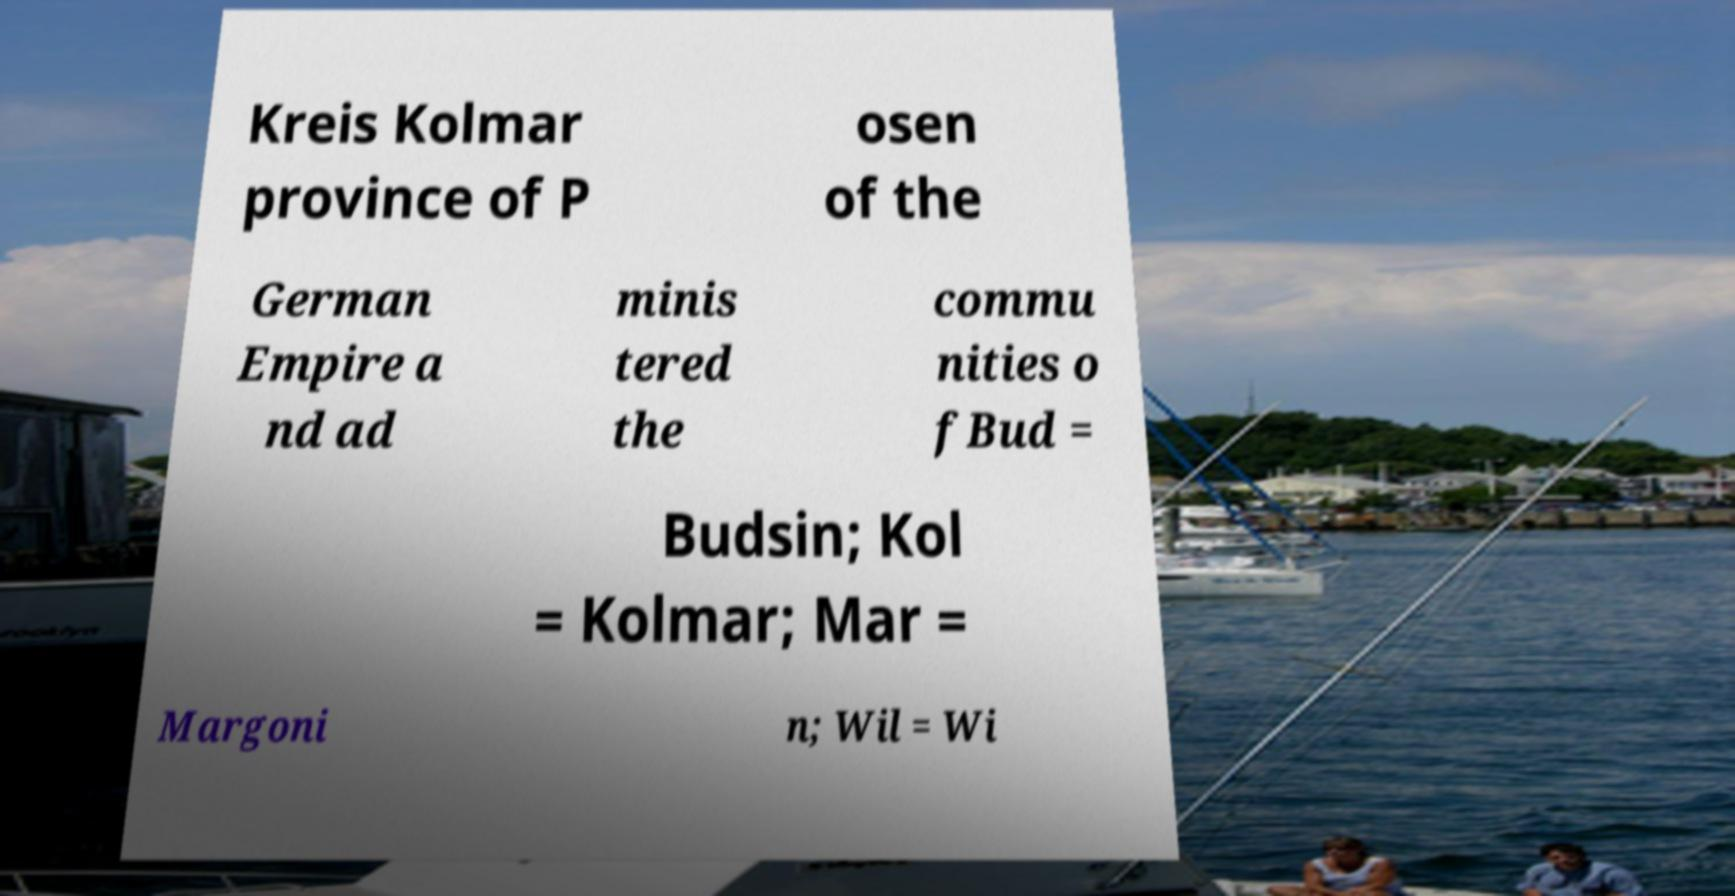Can you accurately transcribe the text from the provided image for me? Kreis Kolmar province of P osen of the German Empire a nd ad minis tered the commu nities o fBud = Budsin; Kol = Kolmar; Mar = Margoni n; Wil = Wi 